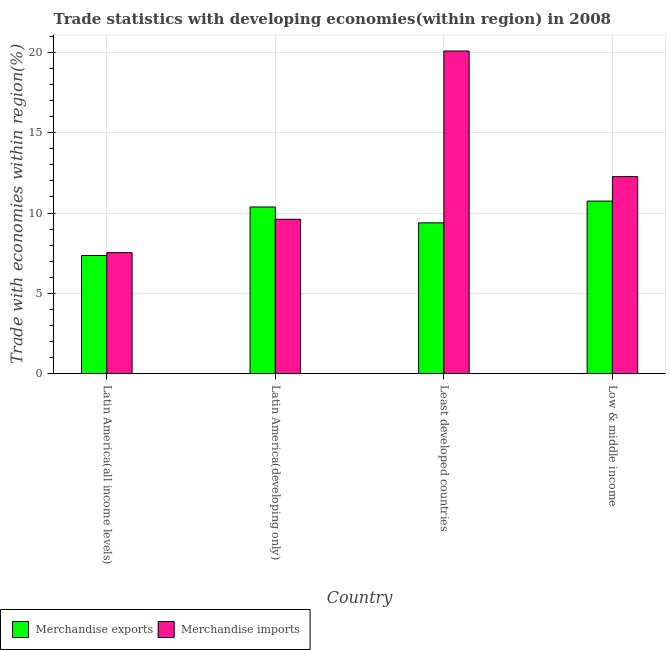How many different coloured bars are there?
Give a very brief answer. 2. Are the number of bars per tick equal to the number of legend labels?
Your answer should be compact. Yes. How many bars are there on the 1st tick from the left?
Provide a succinct answer. 2. How many bars are there on the 2nd tick from the right?
Your answer should be very brief. 2. What is the label of the 2nd group of bars from the left?
Offer a very short reply. Latin America(developing only). In how many cases, is the number of bars for a given country not equal to the number of legend labels?
Make the answer very short. 0. What is the merchandise imports in Latin America(all income levels)?
Provide a short and direct response. 7.53. Across all countries, what is the maximum merchandise imports?
Ensure brevity in your answer.  20.08. Across all countries, what is the minimum merchandise imports?
Offer a very short reply. 7.53. In which country was the merchandise imports minimum?
Provide a succinct answer. Latin America(all income levels). What is the total merchandise exports in the graph?
Give a very brief answer. 37.87. What is the difference between the merchandise exports in Latin America(all income levels) and that in Latin America(developing only)?
Provide a short and direct response. -3.02. What is the difference between the merchandise imports in Latin America(all income levels) and the merchandise exports in Low & middle income?
Offer a terse response. -3.21. What is the average merchandise exports per country?
Your answer should be very brief. 9.47. What is the difference between the merchandise imports and merchandise exports in Latin America(developing only)?
Your response must be concise. -0.76. What is the ratio of the merchandise imports in Latin America(all income levels) to that in Low & middle income?
Ensure brevity in your answer.  0.61. What is the difference between the highest and the second highest merchandise exports?
Your answer should be very brief. 0.37. What is the difference between the highest and the lowest merchandise imports?
Ensure brevity in your answer.  12.55. In how many countries, is the merchandise exports greater than the average merchandise exports taken over all countries?
Your response must be concise. 2. What does the 1st bar from the right in Low & middle income represents?
Ensure brevity in your answer.  Merchandise imports. How many bars are there?
Provide a short and direct response. 8. How many countries are there in the graph?
Keep it short and to the point. 4. Are the values on the major ticks of Y-axis written in scientific E-notation?
Make the answer very short. No. Does the graph contain any zero values?
Your answer should be very brief. No. Does the graph contain grids?
Ensure brevity in your answer.  Yes. How many legend labels are there?
Provide a succinct answer. 2. What is the title of the graph?
Your answer should be very brief. Trade statistics with developing economies(within region) in 2008. What is the label or title of the Y-axis?
Ensure brevity in your answer.  Trade with economies within region(%). What is the Trade with economies within region(%) of Merchandise exports in Latin America(all income levels)?
Give a very brief answer. 7.36. What is the Trade with economies within region(%) in Merchandise imports in Latin America(all income levels)?
Your answer should be very brief. 7.53. What is the Trade with economies within region(%) in Merchandise exports in Latin America(developing only)?
Provide a short and direct response. 10.38. What is the Trade with economies within region(%) of Merchandise imports in Latin America(developing only)?
Offer a terse response. 9.61. What is the Trade with economies within region(%) of Merchandise exports in Least developed countries?
Your answer should be very brief. 9.39. What is the Trade with economies within region(%) in Merchandise imports in Least developed countries?
Ensure brevity in your answer.  20.08. What is the Trade with economies within region(%) of Merchandise exports in Low & middle income?
Offer a very short reply. 10.74. What is the Trade with economies within region(%) of Merchandise imports in Low & middle income?
Your response must be concise. 12.27. Across all countries, what is the maximum Trade with economies within region(%) in Merchandise exports?
Your response must be concise. 10.74. Across all countries, what is the maximum Trade with economies within region(%) in Merchandise imports?
Provide a short and direct response. 20.08. Across all countries, what is the minimum Trade with economies within region(%) of Merchandise exports?
Offer a very short reply. 7.36. Across all countries, what is the minimum Trade with economies within region(%) of Merchandise imports?
Provide a short and direct response. 7.53. What is the total Trade with economies within region(%) of Merchandise exports in the graph?
Give a very brief answer. 37.87. What is the total Trade with economies within region(%) in Merchandise imports in the graph?
Your response must be concise. 49.5. What is the difference between the Trade with economies within region(%) of Merchandise exports in Latin America(all income levels) and that in Latin America(developing only)?
Your response must be concise. -3.02. What is the difference between the Trade with economies within region(%) in Merchandise imports in Latin America(all income levels) and that in Latin America(developing only)?
Your answer should be very brief. -2.08. What is the difference between the Trade with economies within region(%) of Merchandise exports in Latin America(all income levels) and that in Least developed countries?
Offer a terse response. -2.03. What is the difference between the Trade with economies within region(%) in Merchandise imports in Latin America(all income levels) and that in Least developed countries?
Provide a succinct answer. -12.55. What is the difference between the Trade with economies within region(%) of Merchandise exports in Latin America(all income levels) and that in Low & middle income?
Provide a succinct answer. -3.39. What is the difference between the Trade with economies within region(%) in Merchandise imports in Latin America(all income levels) and that in Low & middle income?
Offer a very short reply. -4.73. What is the difference between the Trade with economies within region(%) in Merchandise imports in Latin America(developing only) and that in Least developed countries?
Offer a terse response. -10.47. What is the difference between the Trade with economies within region(%) in Merchandise exports in Latin America(developing only) and that in Low & middle income?
Give a very brief answer. -0.37. What is the difference between the Trade with economies within region(%) of Merchandise imports in Latin America(developing only) and that in Low & middle income?
Offer a terse response. -2.65. What is the difference between the Trade with economies within region(%) in Merchandise exports in Least developed countries and that in Low & middle income?
Provide a succinct answer. -1.35. What is the difference between the Trade with economies within region(%) of Merchandise imports in Least developed countries and that in Low & middle income?
Give a very brief answer. 7.82. What is the difference between the Trade with economies within region(%) of Merchandise exports in Latin America(all income levels) and the Trade with economies within region(%) of Merchandise imports in Latin America(developing only)?
Offer a very short reply. -2.26. What is the difference between the Trade with economies within region(%) of Merchandise exports in Latin America(all income levels) and the Trade with economies within region(%) of Merchandise imports in Least developed countries?
Give a very brief answer. -12.73. What is the difference between the Trade with economies within region(%) in Merchandise exports in Latin America(all income levels) and the Trade with economies within region(%) in Merchandise imports in Low & middle income?
Ensure brevity in your answer.  -4.91. What is the difference between the Trade with economies within region(%) of Merchandise exports in Latin America(developing only) and the Trade with economies within region(%) of Merchandise imports in Least developed countries?
Your answer should be compact. -9.71. What is the difference between the Trade with economies within region(%) in Merchandise exports in Latin America(developing only) and the Trade with economies within region(%) in Merchandise imports in Low & middle income?
Give a very brief answer. -1.89. What is the difference between the Trade with economies within region(%) in Merchandise exports in Least developed countries and the Trade with economies within region(%) in Merchandise imports in Low & middle income?
Provide a succinct answer. -2.88. What is the average Trade with economies within region(%) in Merchandise exports per country?
Make the answer very short. 9.47. What is the average Trade with economies within region(%) in Merchandise imports per country?
Your answer should be compact. 12.37. What is the difference between the Trade with economies within region(%) in Merchandise exports and Trade with economies within region(%) in Merchandise imports in Latin America(all income levels)?
Make the answer very short. -0.18. What is the difference between the Trade with economies within region(%) in Merchandise exports and Trade with economies within region(%) in Merchandise imports in Latin America(developing only)?
Ensure brevity in your answer.  0.76. What is the difference between the Trade with economies within region(%) in Merchandise exports and Trade with economies within region(%) in Merchandise imports in Least developed countries?
Offer a terse response. -10.69. What is the difference between the Trade with economies within region(%) in Merchandise exports and Trade with economies within region(%) in Merchandise imports in Low & middle income?
Your answer should be very brief. -1.52. What is the ratio of the Trade with economies within region(%) of Merchandise exports in Latin America(all income levels) to that in Latin America(developing only)?
Offer a very short reply. 0.71. What is the ratio of the Trade with economies within region(%) in Merchandise imports in Latin America(all income levels) to that in Latin America(developing only)?
Offer a very short reply. 0.78. What is the ratio of the Trade with economies within region(%) of Merchandise exports in Latin America(all income levels) to that in Least developed countries?
Keep it short and to the point. 0.78. What is the ratio of the Trade with economies within region(%) in Merchandise imports in Latin America(all income levels) to that in Least developed countries?
Offer a terse response. 0.38. What is the ratio of the Trade with economies within region(%) in Merchandise exports in Latin America(all income levels) to that in Low & middle income?
Offer a terse response. 0.68. What is the ratio of the Trade with economies within region(%) in Merchandise imports in Latin America(all income levels) to that in Low & middle income?
Offer a terse response. 0.61. What is the ratio of the Trade with economies within region(%) in Merchandise exports in Latin America(developing only) to that in Least developed countries?
Provide a succinct answer. 1.11. What is the ratio of the Trade with economies within region(%) of Merchandise imports in Latin America(developing only) to that in Least developed countries?
Your answer should be very brief. 0.48. What is the ratio of the Trade with economies within region(%) of Merchandise exports in Latin America(developing only) to that in Low & middle income?
Ensure brevity in your answer.  0.97. What is the ratio of the Trade with economies within region(%) of Merchandise imports in Latin America(developing only) to that in Low & middle income?
Your response must be concise. 0.78. What is the ratio of the Trade with economies within region(%) in Merchandise exports in Least developed countries to that in Low & middle income?
Offer a very short reply. 0.87. What is the ratio of the Trade with economies within region(%) of Merchandise imports in Least developed countries to that in Low & middle income?
Your response must be concise. 1.64. What is the difference between the highest and the second highest Trade with economies within region(%) in Merchandise exports?
Your answer should be compact. 0.37. What is the difference between the highest and the second highest Trade with economies within region(%) of Merchandise imports?
Your response must be concise. 7.82. What is the difference between the highest and the lowest Trade with economies within region(%) in Merchandise exports?
Offer a very short reply. 3.39. What is the difference between the highest and the lowest Trade with economies within region(%) of Merchandise imports?
Ensure brevity in your answer.  12.55. 